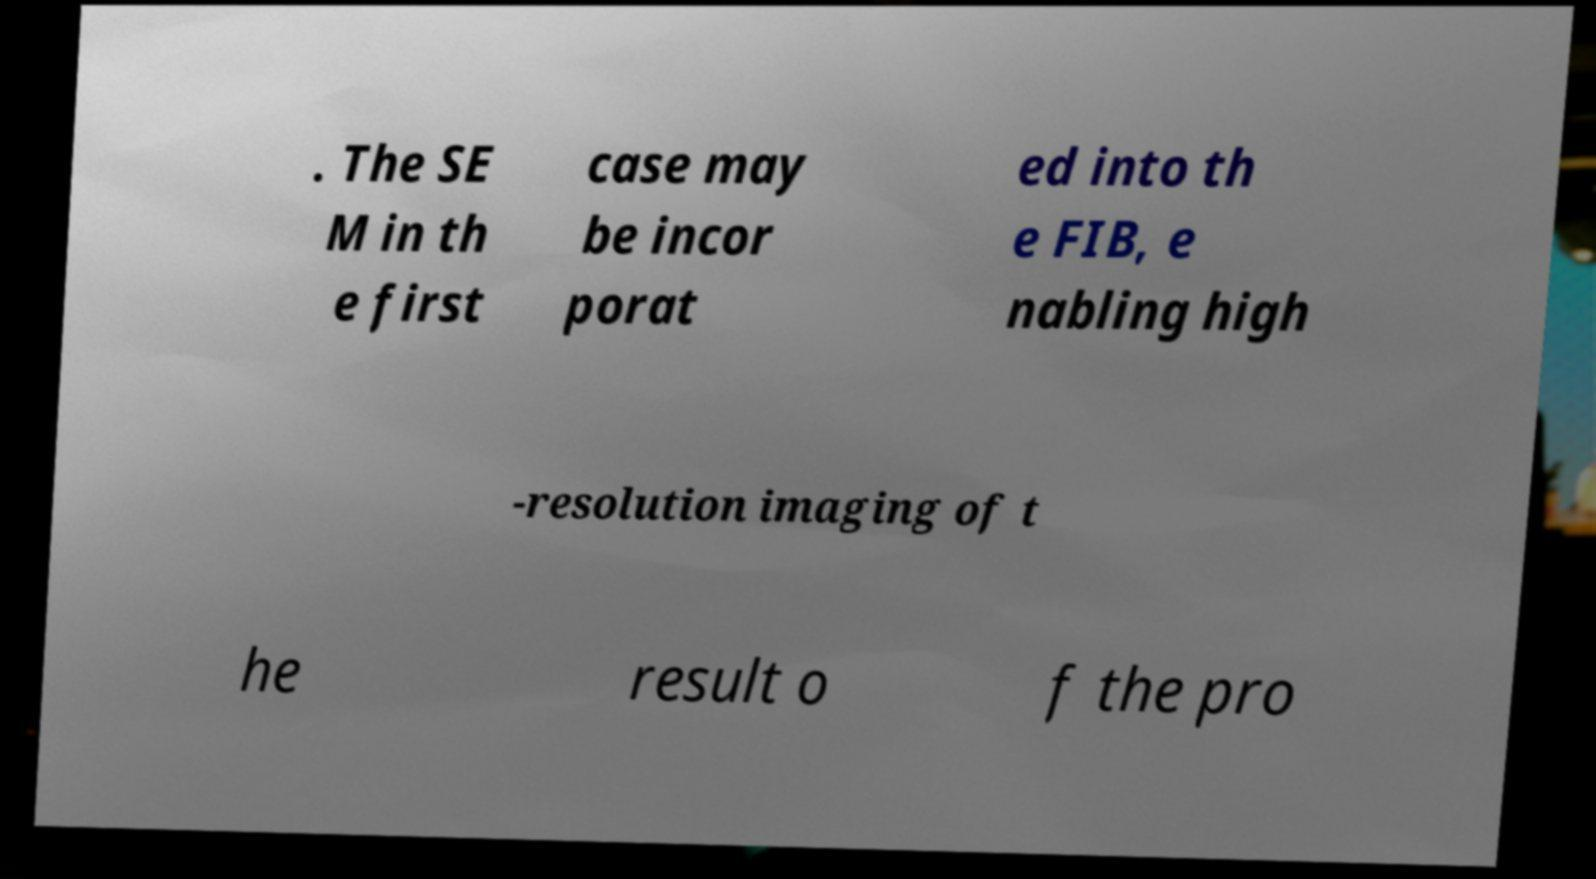I need the written content from this picture converted into text. Can you do that? . The SE M in th e first case may be incor porat ed into th e FIB, e nabling high -resolution imaging of t he result o f the pro 